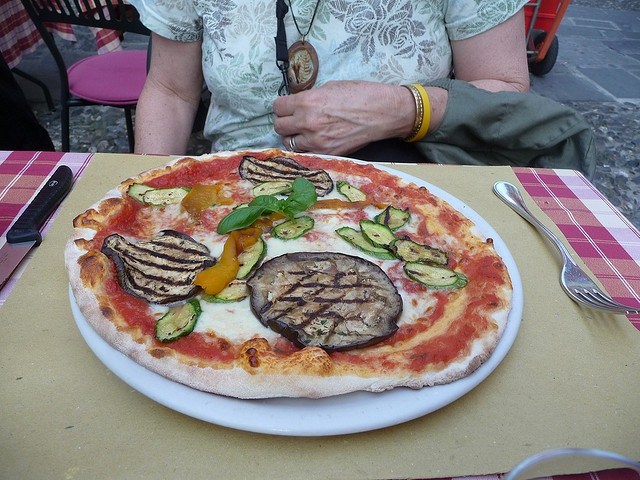Describe the objects in this image and their specific colors. I can see dining table in black, darkgray, gray, and brown tones, pizza in black, brown, darkgray, tan, and lightgray tones, people in black, darkgray, gray, and lightblue tones, chair in black, purple, and gray tones, and cup in black, gray, and darkgray tones in this image. 